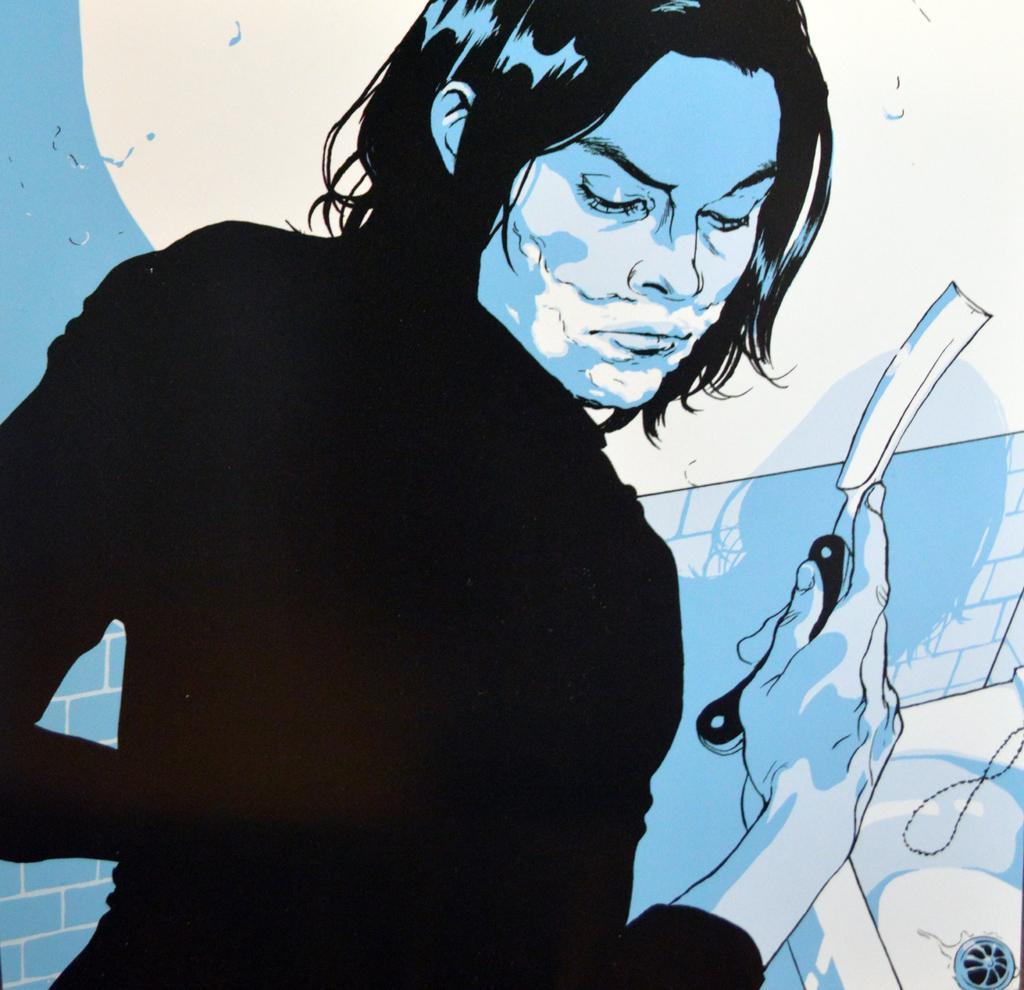Describe this image in one or two sentences. In this image I can see a person is holding an object in hand, sink and wall. This image looks like a painting. 